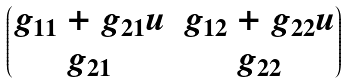<formula> <loc_0><loc_0><loc_500><loc_500>\begin{pmatrix} g _ { 1 1 } + g _ { 2 1 } u & g _ { 1 2 } + g _ { 2 2 } u \\ g _ { 2 1 } & g _ { 2 2 } \end{pmatrix}</formula> 